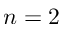Convert formula to latex. <formula><loc_0><loc_0><loc_500><loc_500>n = 2</formula> 